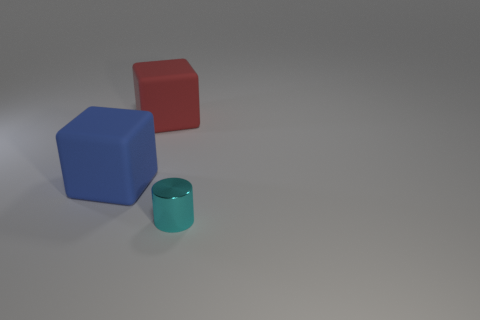Add 3 small metallic things. How many objects exist? 6 Subtract all blue blocks. How many blocks are left? 1 Subtract 1 cylinders. How many cylinders are left? 0 Subtract all cylinders. How many objects are left? 2 Subtract all gray balls. How many blue blocks are left? 1 Subtract all cyan shiny cylinders. Subtract all tiny shiny cylinders. How many objects are left? 1 Add 2 small cyan things. How many small cyan things are left? 3 Add 1 red rubber cylinders. How many red rubber cylinders exist? 1 Subtract 0 green cylinders. How many objects are left? 3 Subtract all red cylinders. Subtract all purple cubes. How many cylinders are left? 1 